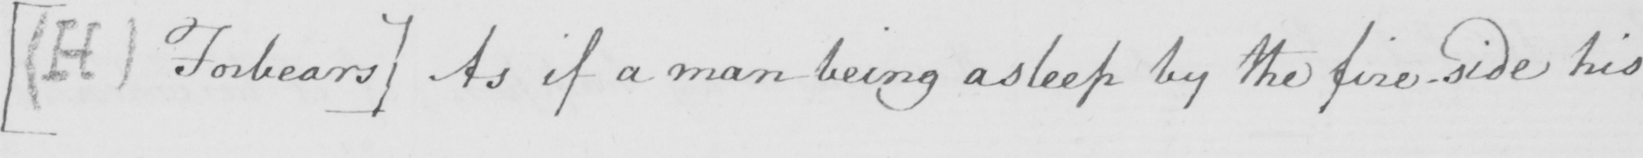Please provide the text content of this handwritten line. [  ( H )  Forbears ]  As if a man being asleep by the fire-side his 